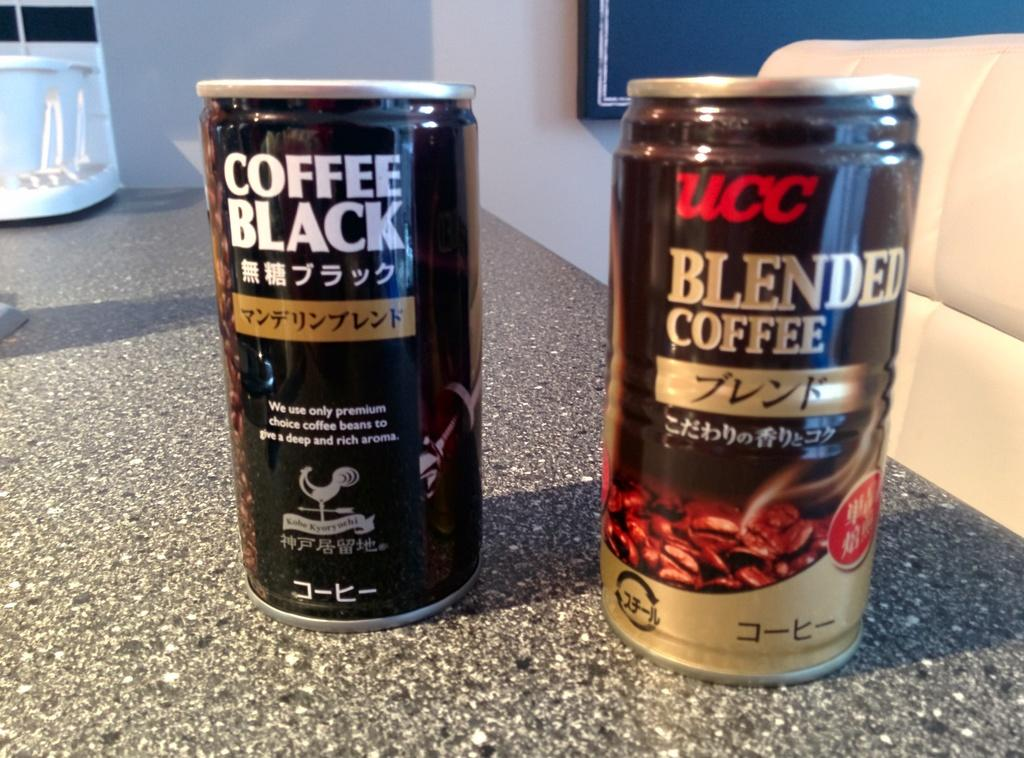<image>
Describe the image concisely. Two small aluminum cans of coffee on a marble counter top. 